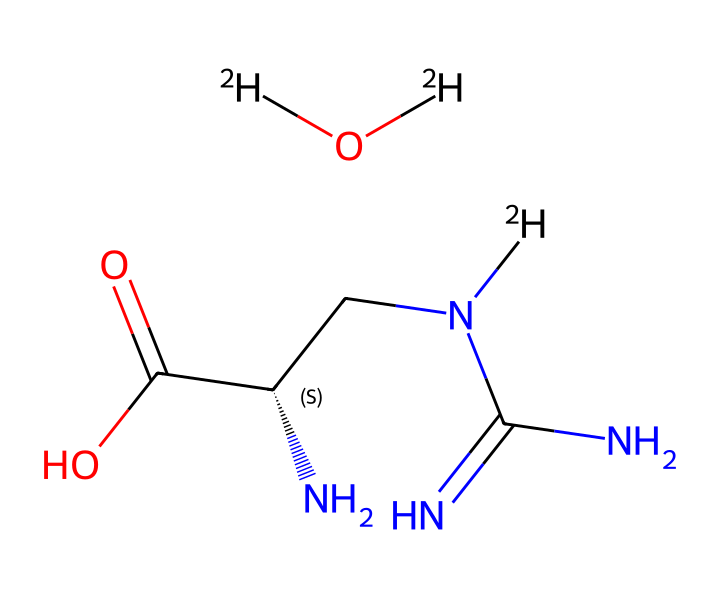What is the molecular formula of deuterated creatine monohydrate? The chemical structure includes both deuterium (represented as [2H]) and standard atoms such as carbon (C), nitrogen (N), oxygen (O), and hydrogen (H). By counting the atoms in the structure, the molecular formula can be derived as C4H10N4O3.
Answer: C4H10N4O3 How many nitrogen atoms are present in deuterated creatine monohydrate? By examining the structure, there are four nitrogen (N) atoms visible. This includes those connected to the carbon chain and in the amine groups.
Answer: 4 What role does deuterium play in this compound? Deuterium, as an isotope of hydrogen, replaces regular hydrogen atoms in the structure, which can affect the compound's properties without changing its essential function. This is significant for research and analysis purposes.
Answer: Isotope replacement Which part of the creatine structure is responsible for the amine properties? The nitrogen atoms are grouped in amine functional groups (–NH and –NH2), which are typically found in creatine and contribute to its basic properties.
Answer: Nitrogen atoms What would be the likely effect of using deuterated creatine in metabolic studies? Using deuterated creatine allows researchers to trace metabolic pathways more effectively through the use of nuclear magnetic resonance (NMR) or mass spectrometry, providing insights into metabolic processes.
Answer: Trace metabolic pathways How many chiral centers are in deuterated creatine monohydrate? Looking at the structure, there is one chiral center indicated by the stereocenter at the carbon atom that connects to the nitrogen and the "-N(CH3)" group.
Answer: 1 